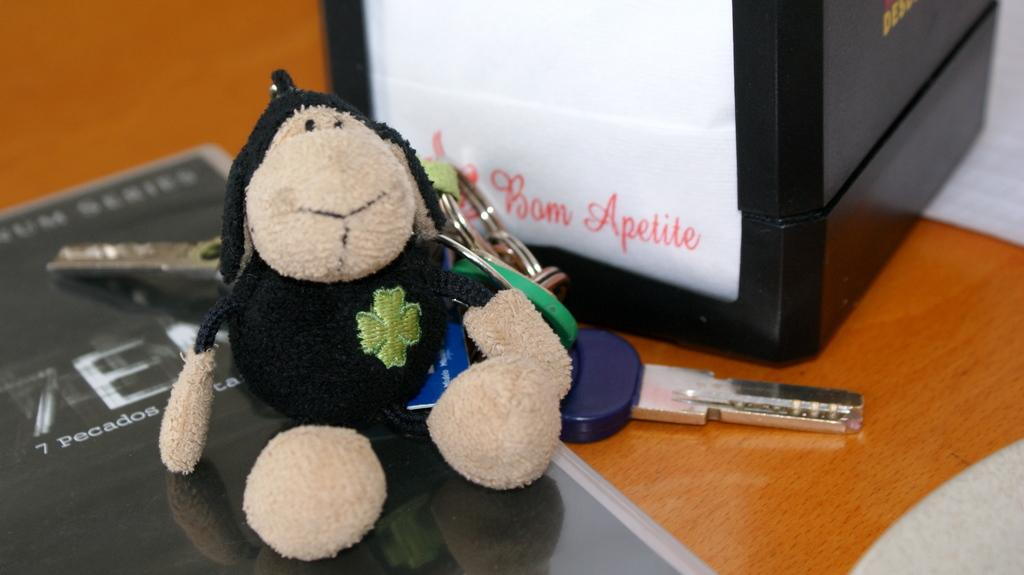What type of object can be seen in the image? There is a toy in the image. What other items are visible in the image? There are keychains, a board, and a box in the image. Can you describe the setting of the image? The image is likely taken in a room. Can you see any trees or firemen in the image? No, there are no trees or firemen present in the image. Is anyone writing in the image? There is no indication of writing or any person writing in the image. 